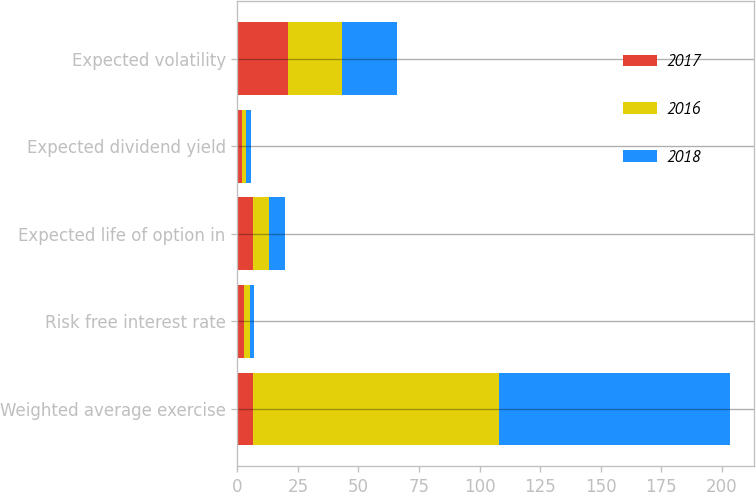<chart> <loc_0><loc_0><loc_500><loc_500><stacked_bar_chart><ecel><fcel>Weighted average exercise<fcel>Risk free interest rate<fcel>Expected life of option in<fcel>Expected dividend yield<fcel>Expected volatility<nl><fcel>2017<fcel>6.5<fcel>2.9<fcel>6.5<fcel>1.7<fcel>21<nl><fcel>2016<fcel>101.53<fcel>2.4<fcel>6.5<fcel>1.8<fcel>22<nl><fcel>2018<fcel>95.29<fcel>1.6<fcel>6.5<fcel>2.1<fcel>22.8<nl></chart> 